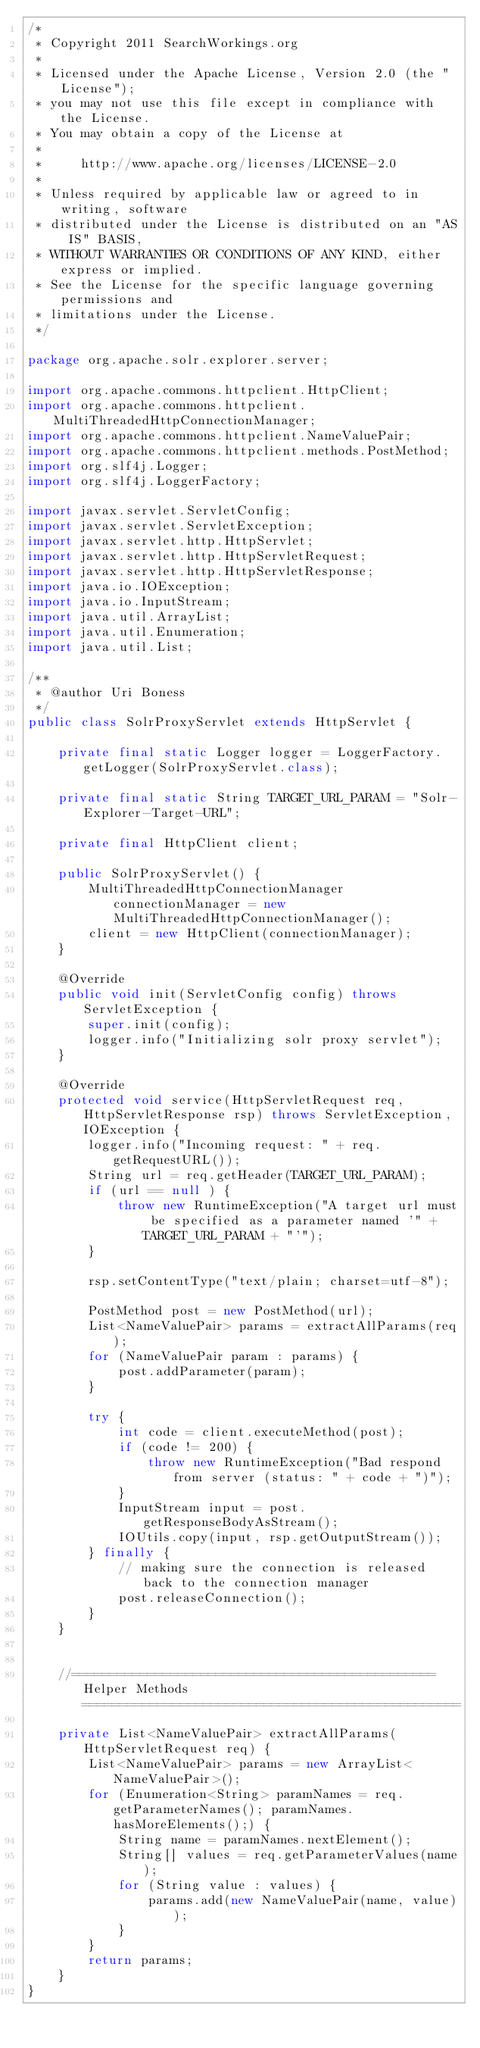Convert code to text. <code><loc_0><loc_0><loc_500><loc_500><_Java_>/*
 * Copyright 2011 SearchWorkings.org
 *
 * Licensed under the Apache License, Version 2.0 (the "License");
 * you may not use this file except in compliance with the License.
 * You may obtain a copy of the License at
 *
 *     http://www.apache.org/licenses/LICENSE-2.0
 *
 * Unless required by applicable law or agreed to in writing, software
 * distributed under the License is distributed on an "AS IS" BASIS,
 * WITHOUT WARRANTIES OR CONDITIONS OF ANY KIND, either express or implied.
 * See the License for the specific language governing permissions and
 * limitations under the License.
 */

package org.apache.solr.explorer.server;

import org.apache.commons.httpclient.HttpClient;
import org.apache.commons.httpclient.MultiThreadedHttpConnectionManager;
import org.apache.commons.httpclient.NameValuePair;
import org.apache.commons.httpclient.methods.PostMethod;
import org.slf4j.Logger;
import org.slf4j.LoggerFactory;

import javax.servlet.ServletConfig;
import javax.servlet.ServletException;
import javax.servlet.http.HttpServlet;
import javax.servlet.http.HttpServletRequest;
import javax.servlet.http.HttpServletResponse;
import java.io.IOException;
import java.io.InputStream;
import java.util.ArrayList;
import java.util.Enumeration;
import java.util.List;

/**
 * @author Uri Boness
 */
public class SolrProxyServlet extends HttpServlet {

    private final static Logger logger = LoggerFactory.getLogger(SolrProxyServlet.class);

    private final static String TARGET_URL_PARAM = "Solr-Explorer-Target-URL";

    private final HttpClient client;

    public SolrProxyServlet() {
        MultiThreadedHttpConnectionManager connectionManager = new MultiThreadedHttpConnectionManager();
        client = new HttpClient(connectionManager);
    }

    @Override
    public void init(ServletConfig config) throws ServletException {
        super.init(config);
        logger.info("Initializing solr proxy servlet");
    }

    @Override
    protected void service(HttpServletRequest req, HttpServletResponse rsp) throws ServletException, IOException {
        logger.info("Incoming request: " + req.getRequestURL());
        String url = req.getHeader(TARGET_URL_PARAM);
        if (url == null ) {
            throw new RuntimeException("A target url must be specified as a parameter named '" + TARGET_URL_PARAM + "'");
        }

        rsp.setContentType("text/plain; charset=utf-8");

        PostMethod post = new PostMethod(url);
        List<NameValuePair> params = extractAllParams(req);
        for (NameValuePair param : params) {
            post.addParameter(param);
        }

        try {
            int code = client.executeMethod(post);
            if (code != 200) {
                throw new RuntimeException("Bad respond from server (status: " + code + ")");
            }
            InputStream input = post.getResponseBodyAsStream();
            IOUtils.copy(input, rsp.getOutputStream());
        } finally {
            // making sure the connection is released back to the connection manager
            post.releaseConnection();
        }
    }


    //================================================ Helper Methods ==================================================

    private List<NameValuePair> extractAllParams(HttpServletRequest req) {
        List<NameValuePair> params = new ArrayList<NameValuePair>();
        for (Enumeration<String> paramNames = req.getParameterNames(); paramNames.hasMoreElements();) {
            String name = paramNames.nextElement();
            String[] values = req.getParameterValues(name);
            for (String value : values) {
                params.add(new NameValuePair(name, value));
            }
        }
        return params;
    }
}
</code> 